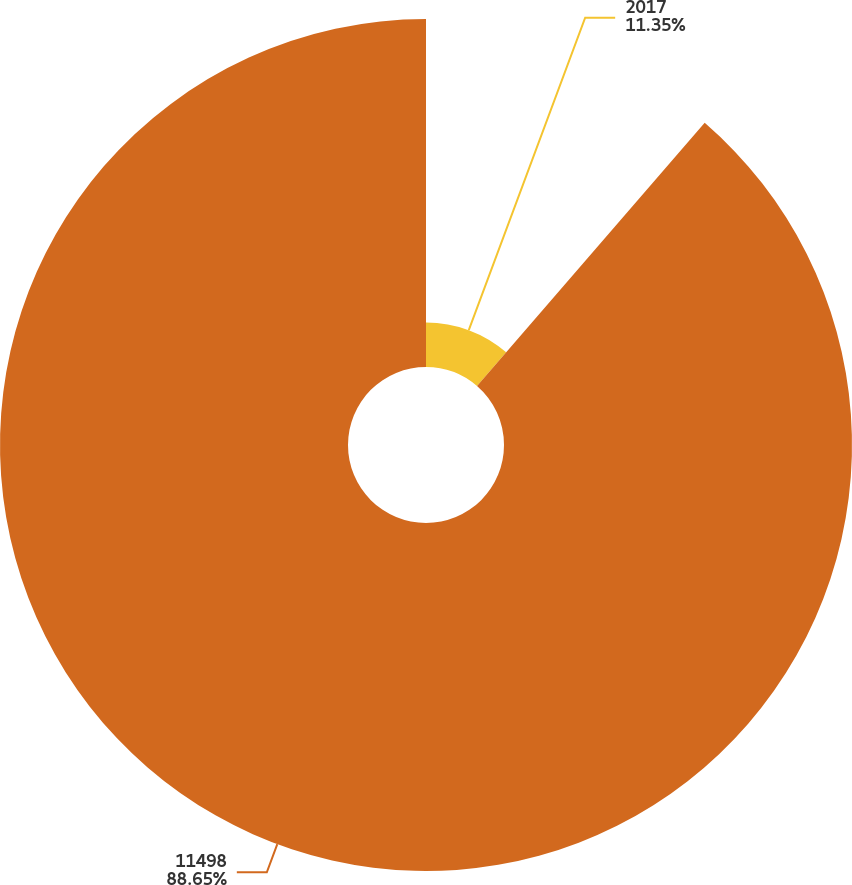<chart> <loc_0><loc_0><loc_500><loc_500><pie_chart><fcel>2017<fcel>11498<nl><fcel>11.35%<fcel>88.65%<nl></chart> 